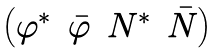Convert formula to latex. <formula><loc_0><loc_0><loc_500><loc_500>\begin{pmatrix} \varphi ^ { * } & \bar { \varphi } & N ^ { * } & \bar { N } \end{pmatrix}</formula> 